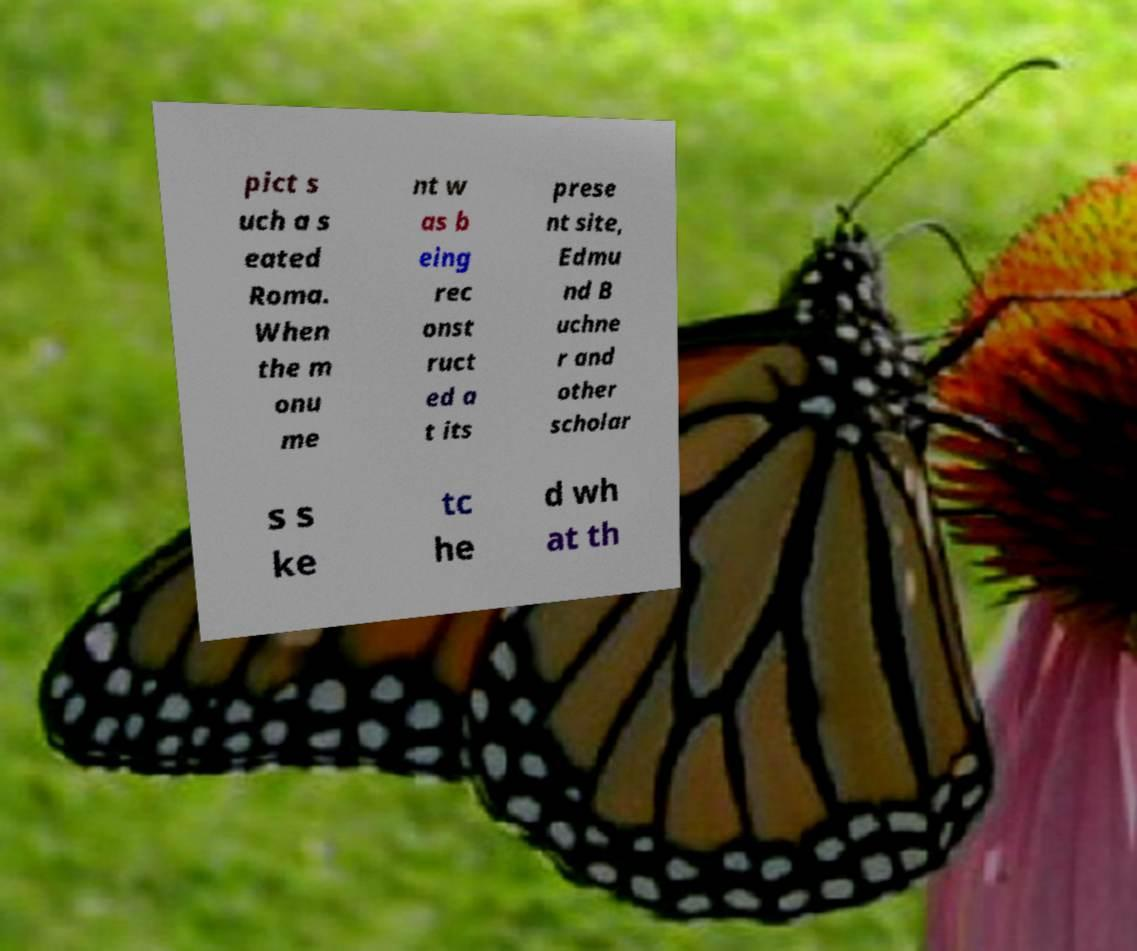For documentation purposes, I need the text within this image transcribed. Could you provide that? pict s uch a s eated Roma. When the m onu me nt w as b eing rec onst ruct ed a t its prese nt site, Edmu nd B uchne r and other scholar s s ke tc he d wh at th 